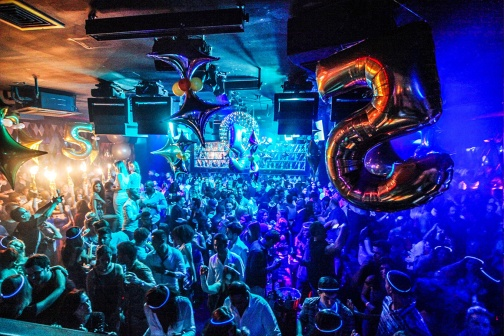What is this photo about? The image captures a vibrant and lively scene from a nightclub, filled with people enjoying a festive celebration. The room is decorated with an array of colorful balloons, predominantly in shades of blue, purple, and silver, with touches of gold and pink adding to the exuberant atmosphere. A pair of large foil balloons, shaped as the numbers '2' and '5', suggests that this is a celebration marking a 25th milestone, like an anniversary or birthday.

The crowd consists of enthusiastic party-goers, many of whom are wearing party hats and holding drinks, contributing to the jubilant mood. They appear to be dancing and socializing, engaging in typical activities associated with a nightclub setting. In the background, a well-stocked bar is visible, with shelves lined with various bottles and glasses, ready to serve the revelers.

The lighting is dim and atmospheric, typical of a nightclub, with blue and purple lights casting a mesmerizing glow over the attendees, enhancing the party vibe. The precise arrangement of people and objects, combined with their actions and the lively environment, paints a vivid picture of a bustling and enjoyable celebration in full swing. 